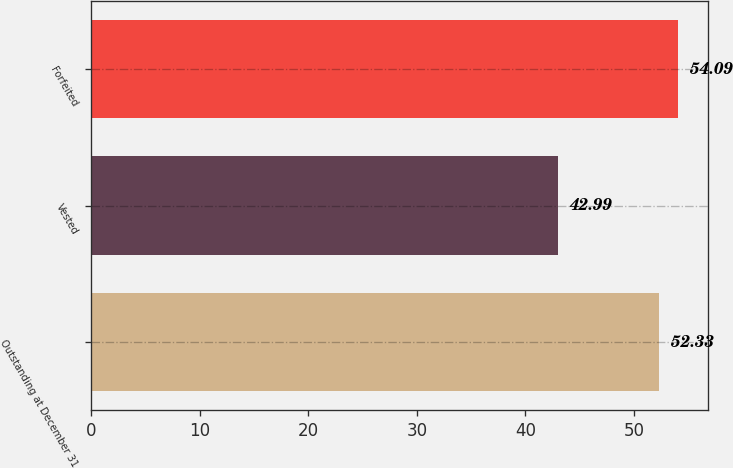Convert chart to OTSL. <chart><loc_0><loc_0><loc_500><loc_500><bar_chart><fcel>Outstanding at December 31<fcel>Vested<fcel>Forfeited<nl><fcel>52.33<fcel>42.99<fcel>54.09<nl></chart> 